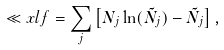Convert formula to latex. <formula><loc_0><loc_0><loc_500><loc_500>\ll x l f = \sum _ { j } \left [ N _ { j } \ln ( \tilde { N } _ { j } ) - \tilde { N } _ { j } \right ] ,</formula> 